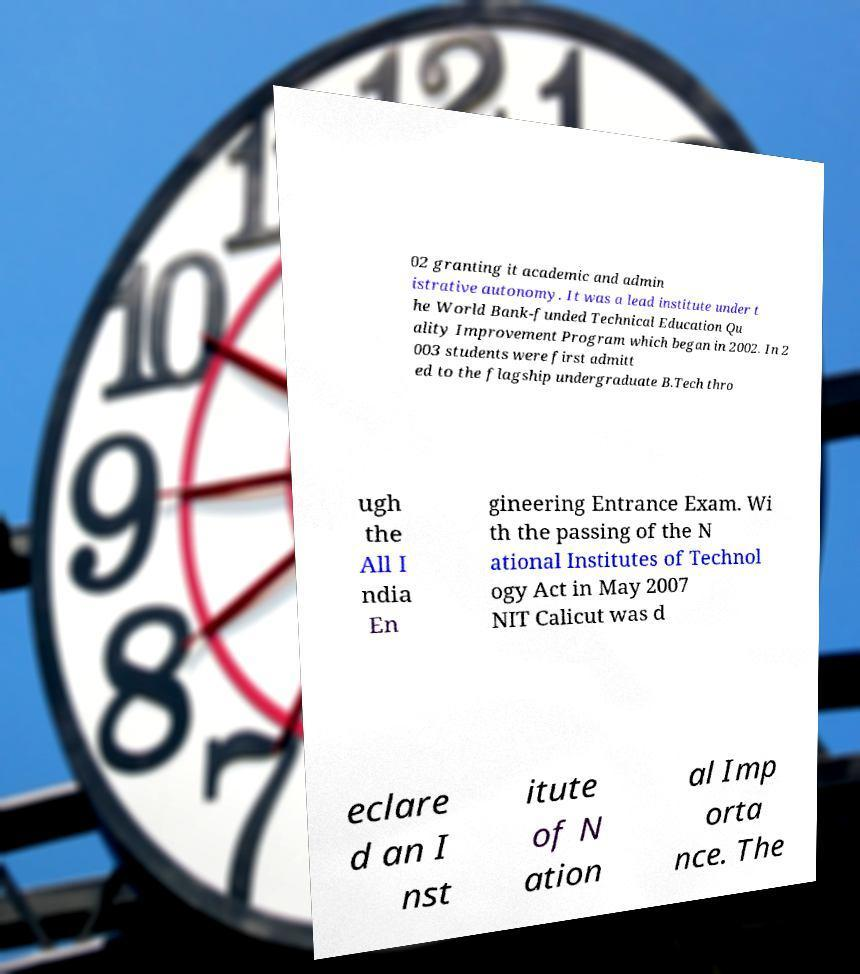I need the written content from this picture converted into text. Can you do that? 02 granting it academic and admin istrative autonomy. It was a lead institute under t he World Bank-funded Technical Education Qu ality Improvement Program which began in 2002. In 2 003 students were first admitt ed to the flagship undergraduate B.Tech thro ugh the All I ndia En gineering Entrance Exam. Wi th the passing of the N ational Institutes of Technol ogy Act in May 2007 NIT Calicut was d eclare d an I nst itute of N ation al Imp orta nce. The 